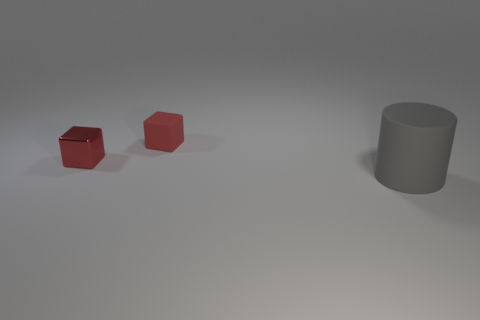Is there anything else that has the same size as the cylinder?
Provide a short and direct response. No. What number of other objects are the same color as the small matte thing?
Your answer should be very brief. 1. Is the color of the large object the same as the rubber thing on the left side of the gray matte cylinder?
Provide a succinct answer. No. How many gray things are matte cylinders or rubber cubes?
Give a very brief answer. 1. Is the number of small red things in front of the big rubber cylinder the same as the number of big gray matte cylinders?
Provide a succinct answer. No. What is the color of the other small thing that is the same shape as the tiny red shiny thing?
Provide a short and direct response. Red. What number of red rubber objects are the same shape as the gray matte object?
Offer a terse response. 0. What is the material of the other small cube that is the same color as the small shiny block?
Ensure brevity in your answer.  Rubber. What number of blue metallic cylinders are there?
Your answer should be very brief. 0. Are there any blocks that have the same material as the large gray object?
Provide a succinct answer. Yes. 